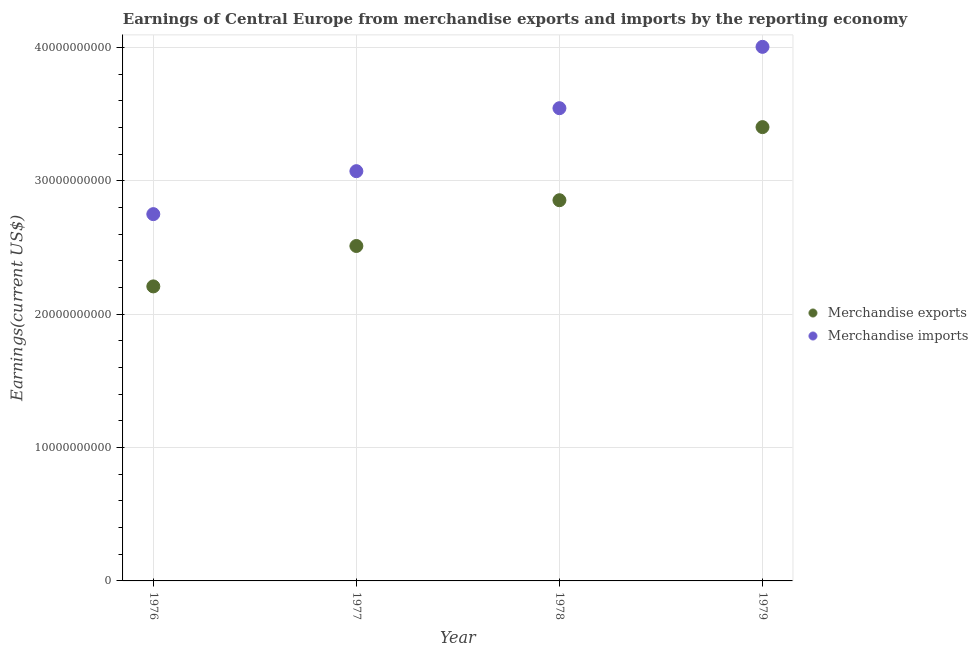How many different coloured dotlines are there?
Your answer should be very brief. 2. Is the number of dotlines equal to the number of legend labels?
Your answer should be very brief. Yes. What is the earnings from merchandise imports in 1979?
Ensure brevity in your answer.  4.00e+1. Across all years, what is the maximum earnings from merchandise exports?
Provide a short and direct response. 3.40e+1. Across all years, what is the minimum earnings from merchandise imports?
Your response must be concise. 2.75e+1. In which year was the earnings from merchandise exports maximum?
Offer a very short reply. 1979. In which year was the earnings from merchandise exports minimum?
Ensure brevity in your answer.  1976. What is the total earnings from merchandise exports in the graph?
Make the answer very short. 1.10e+11. What is the difference between the earnings from merchandise imports in 1977 and that in 1979?
Your answer should be compact. -9.32e+09. What is the difference between the earnings from merchandise exports in 1976 and the earnings from merchandise imports in 1977?
Offer a terse response. -8.64e+09. What is the average earnings from merchandise exports per year?
Offer a very short reply. 2.74e+1. In the year 1976, what is the difference between the earnings from merchandise imports and earnings from merchandise exports?
Your answer should be compact. 5.42e+09. What is the ratio of the earnings from merchandise imports in 1977 to that in 1978?
Ensure brevity in your answer.  0.87. Is the earnings from merchandise exports in 1976 less than that in 1978?
Your answer should be compact. Yes. What is the difference between the highest and the second highest earnings from merchandise imports?
Give a very brief answer. 4.60e+09. What is the difference between the highest and the lowest earnings from merchandise exports?
Ensure brevity in your answer.  1.19e+1. In how many years, is the earnings from merchandise imports greater than the average earnings from merchandise imports taken over all years?
Give a very brief answer. 2. Is the sum of the earnings from merchandise imports in 1976 and 1979 greater than the maximum earnings from merchandise exports across all years?
Provide a short and direct response. Yes. Is the earnings from merchandise imports strictly less than the earnings from merchandise exports over the years?
Offer a very short reply. No. How many years are there in the graph?
Make the answer very short. 4. What is the difference between two consecutive major ticks on the Y-axis?
Offer a very short reply. 1.00e+1. Are the values on the major ticks of Y-axis written in scientific E-notation?
Offer a very short reply. No. Does the graph contain any zero values?
Offer a terse response. No. How are the legend labels stacked?
Provide a succinct answer. Vertical. What is the title of the graph?
Provide a short and direct response. Earnings of Central Europe from merchandise exports and imports by the reporting economy. What is the label or title of the Y-axis?
Your response must be concise. Earnings(current US$). What is the Earnings(current US$) in Merchandise exports in 1976?
Your answer should be compact. 2.21e+1. What is the Earnings(current US$) in Merchandise imports in 1976?
Offer a terse response. 2.75e+1. What is the Earnings(current US$) of Merchandise exports in 1977?
Keep it short and to the point. 2.51e+1. What is the Earnings(current US$) in Merchandise imports in 1977?
Give a very brief answer. 3.07e+1. What is the Earnings(current US$) in Merchandise exports in 1978?
Make the answer very short. 2.85e+1. What is the Earnings(current US$) in Merchandise imports in 1978?
Your answer should be compact. 3.54e+1. What is the Earnings(current US$) in Merchandise exports in 1979?
Your response must be concise. 3.40e+1. What is the Earnings(current US$) of Merchandise imports in 1979?
Make the answer very short. 4.00e+1. Across all years, what is the maximum Earnings(current US$) of Merchandise exports?
Ensure brevity in your answer.  3.40e+1. Across all years, what is the maximum Earnings(current US$) in Merchandise imports?
Ensure brevity in your answer.  4.00e+1. Across all years, what is the minimum Earnings(current US$) of Merchandise exports?
Provide a succinct answer. 2.21e+1. Across all years, what is the minimum Earnings(current US$) of Merchandise imports?
Offer a terse response. 2.75e+1. What is the total Earnings(current US$) in Merchandise exports in the graph?
Offer a terse response. 1.10e+11. What is the total Earnings(current US$) in Merchandise imports in the graph?
Offer a terse response. 1.34e+11. What is the difference between the Earnings(current US$) in Merchandise exports in 1976 and that in 1977?
Your answer should be very brief. -3.03e+09. What is the difference between the Earnings(current US$) in Merchandise imports in 1976 and that in 1977?
Your response must be concise. -3.22e+09. What is the difference between the Earnings(current US$) of Merchandise exports in 1976 and that in 1978?
Your response must be concise. -6.46e+09. What is the difference between the Earnings(current US$) of Merchandise imports in 1976 and that in 1978?
Offer a terse response. -7.94e+09. What is the difference between the Earnings(current US$) of Merchandise exports in 1976 and that in 1979?
Your answer should be very brief. -1.19e+1. What is the difference between the Earnings(current US$) in Merchandise imports in 1976 and that in 1979?
Offer a very short reply. -1.25e+1. What is the difference between the Earnings(current US$) of Merchandise exports in 1977 and that in 1978?
Keep it short and to the point. -3.43e+09. What is the difference between the Earnings(current US$) in Merchandise imports in 1977 and that in 1978?
Make the answer very short. -4.72e+09. What is the difference between the Earnings(current US$) in Merchandise exports in 1977 and that in 1979?
Offer a very short reply. -8.91e+09. What is the difference between the Earnings(current US$) of Merchandise imports in 1977 and that in 1979?
Provide a succinct answer. -9.32e+09. What is the difference between the Earnings(current US$) of Merchandise exports in 1978 and that in 1979?
Your response must be concise. -5.48e+09. What is the difference between the Earnings(current US$) of Merchandise imports in 1978 and that in 1979?
Provide a short and direct response. -4.60e+09. What is the difference between the Earnings(current US$) of Merchandise exports in 1976 and the Earnings(current US$) of Merchandise imports in 1977?
Provide a succinct answer. -8.64e+09. What is the difference between the Earnings(current US$) in Merchandise exports in 1976 and the Earnings(current US$) in Merchandise imports in 1978?
Provide a succinct answer. -1.34e+1. What is the difference between the Earnings(current US$) of Merchandise exports in 1976 and the Earnings(current US$) of Merchandise imports in 1979?
Keep it short and to the point. -1.80e+1. What is the difference between the Earnings(current US$) in Merchandise exports in 1977 and the Earnings(current US$) in Merchandise imports in 1978?
Offer a terse response. -1.03e+1. What is the difference between the Earnings(current US$) of Merchandise exports in 1977 and the Earnings(current US$) of Merchandise imports in 1979?
Offer a terse response. -1.49e+1. What is the difference between the Earnings(current US$) of Merchandise exports in 1978 and the Earnings(current US$) of Merchandise imports in 1979?
Provide a short and direct response. -1.15e+1. What is the average Earnings(current US$) of Merchandise exports per year?
Your answer should be compact. 2.74e+1. What is the average Earnings(current US$) of Merchandise imports per year?
Your response must be concise. 3.34e+1. In the year 1976, what is the difference between the Earnings(current US$) in Merchandise exports and Earnings(current US$) in Merchandise imports?
Keep it short and to the point. -5.42e+09. In the year 1977, what is the difference between the Earnings(current US$) in Merchandise exports and Earnings(current US$) in Merchandise imports?
Give a very brief answer. -5.61e+09. In the year 1978, what is the difference between the Earnings(current US$) of Merchandise exports and Earnings(current US$) of Merchandise imports?
Make the answer very short. -6.90e+09. In the year 1979, what is the difference between the Earnings(current US$) of Merchandise exports and Earnings(current US$) of Merchandise imports?
Provide a short and direct response. -6.02e+09. What is the ratio of the Earnings(current US$) of Merchandise exports in 1976 to that in 1977?
Your answer should be very brief. 0.88. What is the ratio of the Earnings(current US$) in Merchandise imports in 1976 to that in 1977?
Provide a succinct answer. 0.9. What is the ratio of the Earnings(current US$) in Merchandise exports in 1976 to that in 1978?
Your answer should be compact. 0.77. What is the ratio of the Earnings(current US$) of Merchandise imports in 1976 to that in 1978?
Give a very brief answer. 0.78. What is the ratio of the Earnings(current US$) in Merchandise exports in 1976 to that in 1979?
Your answer should be very brief. 0.65. What is the ratio of the Earnings(current US$) in Merchandise imports in 1976 to that in 1979?
Your response must be concise. 0.69. What is the ratio of the Earnings(current US$) in Merchandise exports in 1977 to that in 1978?
Provide a succinct answer. 0.88. What is the ratio of the Earnings(current US$) in Merchandise imports in 1977 to that in 1978?
Your answer should be compact. 0.87. What is the ratio of the Earnings(current US$) of Merchandise exports in 1977 to that in 1979?
Provide a short and direct response. 0.74. What is the ratio of the Earnings(current US$) of Merchandise imports in 1977 to that in 1979?
Offer a terse response. 0.77. What is the ratio of the Earnings(current US$) of Merchandise exports in 1978 to that in 1979?
Give a very brief answer. 0.84. What is the ratio of the Earnings(current US$) of Merchandise imports in 1978 to that in 1979?
Provide a succinct answer. 0.89. What is the difference between the highest and the second highest Earnings(current US$) in Merchandise exports?
Give a very brief answer. 5.48e+09. What is the difference between the highest and the second highest Earnings(current US$) of Merchandise imports?
Provide a short and direct response. 4.60e+09. What is the difference between the highest and the lowest Earnings(current US$) of Merchandise exports?
Your answer should be compact. 1.19e+1. What is the difference between the highest and the lowest Earnings(current US$) in Merchandise imports?
Offer a very short reply. 1.25e+1. 